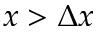Convert formula to latex. <formula><loc_0><loc_0><loc_500><loc_500>x > \Delta x</formula> 